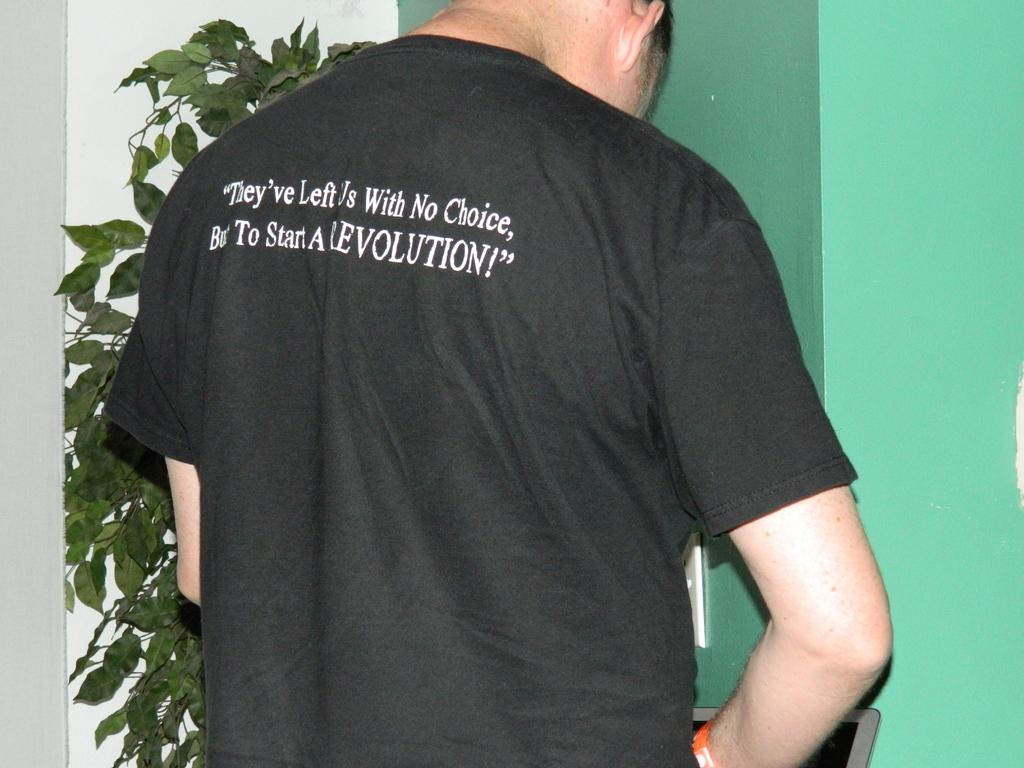<image>
Render a clear and concise summary of the photo. A man wearing a revolution shirt is working on a computer. 